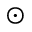Convert formula to latex. <formula><loc_0><loc_0><loc_500><loc_500>\odot</formula> 